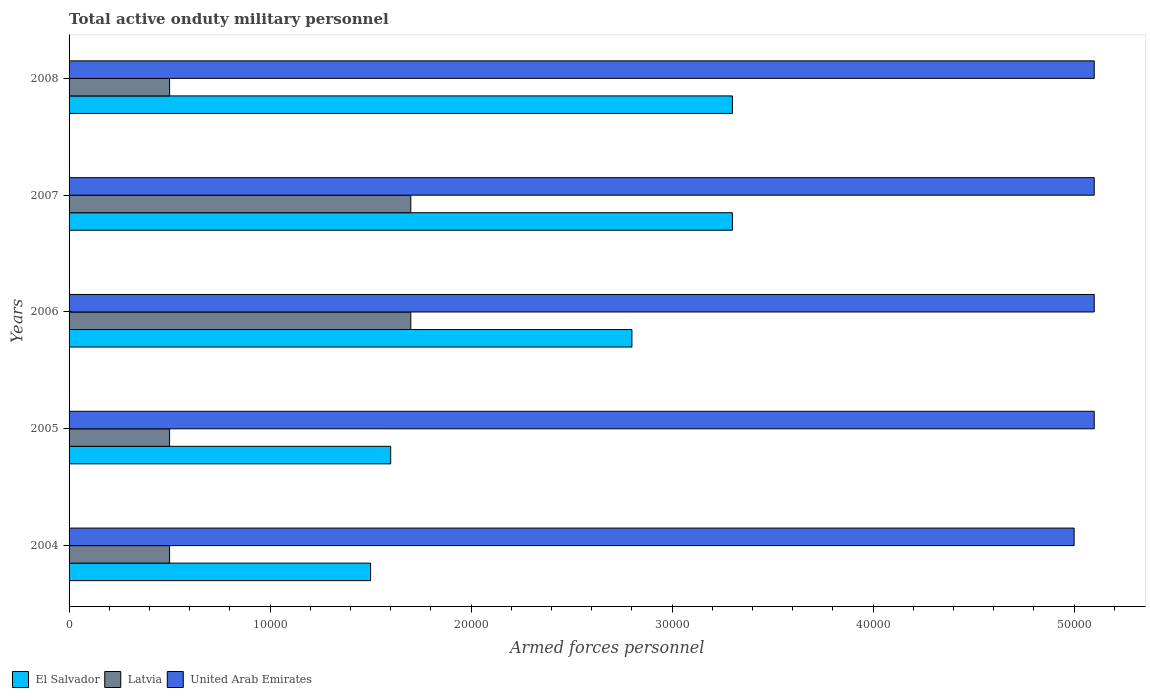How many groups of bars are there?
Your answer should be compact. 5. Are the number of bars per tick equal to the number of legend labels?
Provide a short and direct response. Yes. Are the number of bars on each tick of the Y-axis equal?
Your answer should be very brief. Yes. How many bars are there on the 1st tick from the top?
Offer a terse response. 3. How many bars are there on the 1st tick from the bottom?
Offer a terse response. 3. What is the label of the 1st group of bars from the top?
Provide a short and direct response. 2008. In how many cases, is the number of bars for a given year not equal to the number of legend labels?
Provide a short and direct response. 0. What is the number of armed forces personnel in El Salvador in 2005?
Keep it short and to the point. 1.60e+04. Across all years, what is the maximum number of armed forces personnel in Latvia?
Provide a succinct answer. 1.70e+04. Across all years, what is the minimum number of armed forces personnel in United Arab Emirates?
Provide a short and direct response. 5.00e+04. In which year was the number of armed forces personnel in United Arab Emirates maximum?
Give a very brief answer. 2005. In which year was the number of armed forces personnel in El Salvador minimum?
Ensure brevity in your answer.  2004. What is the total number of armed forces personnel in United Arab Emirates in the graph?
Your response must be concise. 2.54e+05. What is the difference between the number of armed forces personnel in United Arab Emirates in 2004 and the number of armed forces personnel in El Salvador in 2006?
Your answer should be very brief. 2.20e+04. What is the average number of armed forces personnel in Latvia per year?
Offer a very short reply. 9800. In the year 2007, what is the difference between the number of armed forces personnel in Latvia and number of armed forces personnel in El Salvador?
Offer a very short reply. -1.60e+04. What is the ratio of the number of armed forces personnel in Latvia in 2004 to that in 2005?
Provide a short and direct response. 1. Is the difference between the number of armed forces personnel in Latvia in 2004 and 2006 greater than the difference between the number of armed forces personnel in El Salvador in 2004 and 2006?
Provide a succinct answer. Yes. What is the difference between the highest and the second highest number of armed forces personnel in United Arab Emirates?
Your answer should be compact. 0. What is the difference between the highest and the lowest number of armed forces personnel in El Salvador?
Offer a terse response. 1.80e+04. In how many years, is the number of armed forces personnel in El Salvador greater than the average number of armed forces personnel in El Salvador taken over all years?
Ensure brevity in your answer.  3. What does the 2nd bar from the top in 2004 represents?
Make the answer very short. Latvia. What does the 2nd bar from the bottom in 2006 represents?
Offer a very short reply. Latvia. What is the difference between two consecutive major ticks on the X-axis?
Your answer should be compact. 10000. Where does the legend appear in the graph?
Provide a short and direct response. Bottom left. How many legend labels are there?
Offer a terse response. 3. How are the legend labels stacked?
Make the answer very short. Horizontal. What is the title of the graph?
Offer a very short reply. Total active onduty military personnel. What is the label or title of the X-axis?
Your answer should be very brief. Armed forces personnel. What is the label or title of the Y-axis?
Offer a very short reply. Years. What is the Armed forces personnel in El Salvador in 2004?
Your answer should be very brief. 1.50e+04. What is the Armed forces personnel in Latvia in 2004?
Your answer should be very brief. 5000. What is the Armed forces personnel in United Arab Emirates in 2004?
Your answer should be compact. 5.00e+04. What is the Armed forces personnel of El Salvador in 2005?
Offer a very short reply. 1.60e+04. What is the Armed forces personnel in Latvia in 2005?
Your response must be concise. 5000. What is the Armed forces personnel of United Arab Emirates in 2005?
Your answer should be very brief. 5.10e+04. What is the Armed forces personnel in El Salvador in 2006?
Offer a terse response. 2.80e+04. What is the Armed forces personnel in Latvia in 2006?
Your response must be concise. 1.70e+04. What is the Armed forces personnel in United Arab Emirates in 2006?
Offer a terse response. 5.10e+04. What is the Armed forces personnel in El Salvador in 2007?
Provide a short and direct response. 3.30e+04. What is the Armed forces personnel in Latvia in 2007?
Offer a very short reply. 1.70e+04. What is the Armed forces personnel of United Arab Emirates in 2007?
Your answer should be compact. 5.10e+04. What is the Armed forces personnel of El Salvador in 2008?
Offer a terse response. 3.30e+04. What is the Armed forces personnel in United Arab Emirates in 2008?
Your response must be concise. 5.10e+04. Across all years, what is the maximum Armed forces personnel of El Salvador?
Make the answer very short. 3.30e+04. Across all years, what is the maximum Armed forces personnel in Latvia?
Provide a short and direct response. 1.70e+04. Across all years, what is the maximum Armed forces personnel of United Arab Emirates?
Keep it short and to the point. 5.10e+04. Across all years, what is the minimum Armed forces personnel in El Salvador?
Your response must be concise. 1.50e+04. What is the total Armed forces personnel in El Salvador in the graph?
Your answer should be very brief. 1.25e+05. What is the total Armed forces personnel in Latvia in the graph?
Make the answer very short. 4.90e+04. What is the total Armed forces personnel in United Arab Emirates in the graph?
Your response must be concise. 2.54e+05. What is the difference between the Armed forces personnel of El Salvador in 2004 and that in 2005?
Provide a short and direct response. -1000. What is the difference between the Armed forces personnel of Latvia in 2004 and that in 2005?
Give a very brief answer. 0. What is the difference between the Armed forces personnel of United Arab Emirates in 2004 and that in 2005?
Provide a succinct answer. -1000. What is the difference between the Armed forces personnel in El Salvador in 2004 and that in 2006?
Offer a terse response. -1.30e+04. What is the difference between the Armed forces personnel in Latvia in 2004 and that in 2006?
Offer a very short reply. -1.20e+04. What is the difference between the Armed forces personnel in United Arab Emirates in 2004 and that in 2006?
Ensure brevity in your answer.  -1000. What is the difference between the Armed forces personnel in El Salvador in 2004 and that in 2007?
Offer a terse response. -1.80e+04. What is the difference between the Armed forces personnel in Latvia in 2004 and that in 2007?
Give a very brief answer. -1.20e+04. What is the difference between the Armed forces personnel in United Arab Emirates in 2004 and that in 2007?
Offer a terse response. -1000. What is the difference between the Armed forces personnel in El Salvador in 2004 and that in 2008?
Your answer should be very brief. -1.80e+04. What is the difference between the Armed forces personnel in United Arab Emirates in 2004 and that in 2008?
Your answer should be compact. -1000. What is the difference between the Armed forces personnel of El Salvador in 2005 and that in 2006?
Offer a very short reply. -1.20e+04. What is the difference between the Armed forces personnel in Latvia in 2005 and that in 2006?
Offer a terse response. -1.20e+04. What is the difference between the Armed forces personnel in United Arab Emirates in 2005 and that in 2006?
Offer a terse response. 0. What is the difference between the Armed forces personnel of El Salvador in 2005 and that in 2007?
Provide a short and direct response. -1.70e+04. What is the difference between the Armed forces personnel of Latvia in 2005 and that in 2007?
Provide a short and direct response. -1.20e+04. What is the difference between the Armed forces personnel of El Salvador in 2005 and that in 2008?
Your response must be concise. -1.70e+04. What is the difference between the Armed forces personnel in Latvia in 2005 and that in 2008?
Provide a short and direct response. 0. What is the difference between the Armed forces personnel in United Arab Emirates in 2005 and that in 2008?
Give a very brief answer. 0. What is the difference between the Armed forces personnel of El Salvador in 2006 and that in 2007?
Give a very brief answer. -5000. What is the difference between the Armed forces personnel of United Arab Emirates in 2006 and that in 2007?
Offer a very short reply. 0. What is the difference between the Armed forces personnel in El Salvador in 2006 and that in 2008?
Keep it short and to the point. -5000. What is the difference between the Armed forces personnel in Latvia in 2006 and that in 2008?
Ensure brevity in your answer.  1.20e+04. What is the difference between the Armed forces personnel of Latvia in 2007 and that in 2008?
Give a very brief answer. 1.20e+04. What is the difference between the Armed forces personnel in United Arab Emirates in 2007 and that in 2008?
Ensure brevity in your answer.  0. What is the difference between the Armed forces personnel of El Salvador in 2004 and the Armed forces personnel of United Arab Emirates in 2005?
Provide a succinct answer. -3.60e+04. What is the difference between the Armed forces personnel in Latvia in 2004 and the Armed forces personnel in United Arab Emirates in 2005?
Your response must be concise. -4.60e+04. What is the difference between the Armed forces personnel of El Salvador in 2004 and the Armed forces personnel of Latvia in 2006?
Your answer should be very brief. -2000. What is the difference between the Armed forces personnel of El Salvador in 2004 and the Armed forces personnel of United Arab Emirates in 2006?
Keep it short and to the point. -3.60e+04. What is the difference between the Armed forces personnel of Latvia in 2004 and the Armed forces personnel of United Arab Emirates in 2006?
Provide a succinct answer. -4.60e+04. What is the difference between the Armed forces personnel in El Salvador in 2004 and the Armed forces personnel in Latvia in 2007?
Offer a very short reply. -2000. What is the difference between the Armed forces personnel in El Salvador in 2004 and the Armed forces personnel in United Arab Emirates in 2007?
Make the answer very short. -3.60e+04. What is the difference between the Armed forces personnel in Latvia in 2004 and the Armed forces personnel in United Arab Emirates in 2007?
Your answer should be very brief. -4.60e+04. What is the difference between the Armed forces personnel of El Salvador in 2004 and the Armed forces personnel of Latvia in 2008?
Make the answer very short. 10000. What is the difference between the Armed forces personnel in El Salvador in 2004 and the Armed forces personnel in United Arab Emirates in 2008?
Ensure brevity in your answer.  -3.60e+04. What is the difference between the Armed forces personnel of Latvia in 2004 and the Armed forces personnel of United Arab Emirates in 2008?
Give a very brief answer. -4.60e+04. What is the difference between the Armed forces personnel of El Salvador in 2005 and the Armed forces personnel of Latvia in 2006?
Your answer should be compact. -1000. What is the difference between the Armed forces personnel in El Salvador in 2005 and the Armed forces personnel in United Arab Emirates in 2006?
Provide a short and direct response. -3.50e+04. What is the difference between the Armed forces personnel in Latvia in 2005 and the Armed forces personnel in United Arab Emirates in 2006?
Keep it short and to the point. -4.60e+04. What is the difference between the Armed forces personnel of El Salvador in 2005 and the Armed forces personnel of Latvia in 2007?
Your answer should be compact. -1000. What is the difference between the Armed forces personnel in El Salvador in 2005 and the Armed forces personnel in United Arab Emirates in 2007?
Provide a short and direct response. -3.50e+04. What is the difference between the Armed forces personnel of Latvia in 2005 and the Armed forces personnel of United Arab Emirates in 2007?
Ensure brevity in your answer.  -4.60e+04. What is the difference between the Armed forces personnel of El Salvador in 2005 and the Armed forces personnel of Latvia in 2008?
Your answer should be very brief. 1.10e+04. What is the difference between the Armed forces personnel in El Salvador in 2005 and the Armed forces personnel in United Arab Emirates in 2008?
Offer a terse response. -3.50e+04. What is the difference between the Armed forces personnel in Latvia in 2005 and the Armed forces personnel in United Arab Emirates in 2008?
Your response must be concise. -4.60e+04. What is the difference between the Armed forces personnel in El Salvador in 2006 and the Armed forces personnel in Latvia in 2007?
Provide a succinct answer. 1.10e+04. What is the difference between the Armed forces personnel in El Salvador in 2006 and the Armed forces personnel in United Arab Emirates in 2007?
Offer a terse response. -2.30e+04. What is the difference between the Armed forces personnel of Latvia in 2006 and the Armed forces personnel of United Arab Emirates in 2007?
Provide a succinct answer. -3.40e+04. What is the difference between the Armed forces personnel in El Salvador in 2006 and the Armed forces personnel in Latvia in 2008?
Provide a short and direct response. 2.30e+04. What is the difference between the Armed forces personnel in El Salvador in 2006 and the Armed forces personnel in United Arab Emirates in 2008?
Keep it short and to the point. -2.30e+04. What is the difference between the Armed forces personnel of Latvia in 2006 and the Armed forces personnel of United Arab Emirates in 2008?
Provide a succinct answer. -3.40e+04. What is the difference between the Armed forces personnel in El Salvador in 2007 and the Armed forces personnel in Latvia in 2008?
Provide a succinct answer. 2.80e+04. What is the difference between the Armed forces personnel of El Salvador in 2007 and the Armed forces personnel of United Arab Emirates in 2008?
Your answer should be compact. -1.80e+04. What is the difference between the Armed forces personnel of Latvia in 2007 and the Armed forces personnel of United Arab Emirates in 2008?
Offer a terse response. -3.40e+04. What is the average Armed forces personnel in El Salvador per year?
Keep it short and to the point. 2.50e+04. What is the average Armed forces personnel in Latvia per year?
Offer a terse response. 9800. What is the average Armed forces personnel in United Arab Emirates per year?
Offer a very short reply. 5.08e+04. In the year 2004, what is the difference between the Armed forces personnel of El Salvador and Armed forces personnel of Latvia?
Your response must be concise. 10000. In the year 2004, what is the difference between the Armed forces personnel in El Salvador and Armed forces personnel in United Arab Emirates?
Provide a succinct answer. -3.50e+04. In the year 2004, what is the difference between the Armed forces personnel in Latvia and Armed forces personnel in United Arab Emirates?
Your answer should be very brief. -4.50e+04. In the year 2005, what is the difference between the Armed forces personnel in El Salvador and Armed forces personnel in Latvia?
Offer a very short reply. 1.10e+04. In the year 2005, what is the difference between the Armed forces personnel of El Salvador and Armed forces personnel of United Arab Emirates?
Keep it short and to the point. -3.50e+04. In the year 2005, what is the difference between the Armed forces personnel in Latvia and Armed forces personnel in United Arab Emirates?
Offer a very short reply. -4.60e+04. In the year 2006, what is the difference between the Armed forces personnel in El Salvador and Armed forces personnel in Latvia?
Offer a terse response. 1.10e+04. In the year 2006, what is the difference between the Armed forces personnel in El Salvador and Armed forces personnel in United Arab Emirates?
Make the answer very short. -2.30e+04. In the year 2006, what is the difference between the Armed forces personnel of Latvia and Armed forces personnel of United Arab Emirates?
Your answer should be compact. -3.40e+04. In the year 2007, what is the difference between the Armed forces personnel in El Salvador and Armed forces personnel in Latvia?
Your response must be concise. 1.60e+04. In the year 2007, what is the difference between the Armed forces personnel of El Salvador and Armed forces personnel of United Arab Emirates?
Your answer should be compact. -1.80e+04. In the year 2007, what is the difference between the Armed forces personnel of Latvia and Armed forces personnel of United Arab Emirates?
Offer a very short reply. -3.40e+04. In the year 2008, what is the difference between the Armed forces personnel in El Salvador and Armed forces personnel in Latvia?
Offer a terse response. 2.80e+04. In the year 2008, what is the difference between the Armed forces personnel in El Salvador and Armed forces personnel in United Arab Emirates?
Give a very brief answer. -1.80e+04. In the year 2008, what is the difference between the Armed forces personnel of Latvia and Armed forces personnel of United Arab Emirates?
Provide a succinct answer. -4.60e+04. What is the ratio of the Armed forces personnel in Latvia in 2004 to that in 2005?
Your answer should be very brief. 1. What is the ratio of the Armed forces personnel in United Arab Emirates in 2004 to that in 2005?
Offer a terse response. 0.98. What is the ratio of the Armed forces personnel of El Salvador in 2004 to that in 2006?
Your answer should be compact. 0.54. What is the ratio of the Armed forces personnel in Latvia in 2004 to that in 2006?
Offer a very short reply. 0.29. What is the ratio of the Armed forces personnel in United Arab Emirates in 2004 to that in 2006?
Offer a terse response. 0.98. What is the ratio of the Armed forces personnel of El Salvador in 2004 to that in 2007?
Your response must be concise. 0.45. What is the ratio of the Armed forces personnel of Latvia in 2004 to that in 2007?
Ensure brevity in your answer.  0.29. What is the ratio of the Armed forces personnel of United Arab Emirates in 2004 to that in 2007?
Your answer should be very brief. 0.98. What is the ratio of the Armed forces personnel of El Salvador in 2004 to that in 2008?
Your answer should be compact. 0.45. What is the ratio of the Armed forces personnel of Latvia in 2004 to that in 2008?
Provide a succinct answer. 1. What is the ratio of the Armed forces personnel in United Arab Emirates in 2004 to that in 2008?
Ensure brevity in your answer.  0.98. What is the ratio of the Armed forces personnel of Latvia in 2005 to that in 2006?
Offer a terse response. 0.29. What is the ratio of the Armed forces personnel in El Salvador in 2005 to that in 2007?
Offer a terse response. 0.48. What is the ratio of the Armed forces personnel in Latvia in 2005 to that in 2007?
Make the answer very short. 0.29. What is the ratio of the Armed forces personnel in United Arab Emirates in 2005 to that in 2007?
Your answer should be compact. 1. What is the ratio of the Armed forces personnel in El Salvador in 2005 to that in 2008?
Provide a short and direct response. 0.48. What is the ratio of the Armed forces personnel of El Salvador in 2006 to that in 2007?
Provide a succinct answer. 0.85. What is the ratio of the Armed forces personnel of Latvia in 2006 to that in 2007?
Provide a succinct answer. 1. What is the ratio of the Armed forces personnel in United Arab Emirates in 2006 to that in 2007?
Your answer should be very brief. 1. What is the ratio of the Armed forces personnel in El Salvador in 2006 to that in 2008?
Offer a very short reply. 0.85. What is the ratio of the Armed forces personnel of Latvia in 2007 to that in 2008?
Provide a short and direct response. 3.4. What is the difference between the highest and the second highest Armed forces personnel in El Salvador?
Offer a very short reply. 0. What is the difference between the highest and the second highest Armed forces personnel of Latvia?
Give a very brief answer. 0. What is the difference between the highest and the second highest Armed forces personnel of United Arab Emirates?
Make the answer very short. 0. What is the difference between the highest and the lowest Armed forces personnel of El Salvador?
Give a very brief answer. 1.80e+04. What is the difference between the highest and the lowest Armed forces personnel of Latvia?
Make the answer very short. 1.20e+04. 